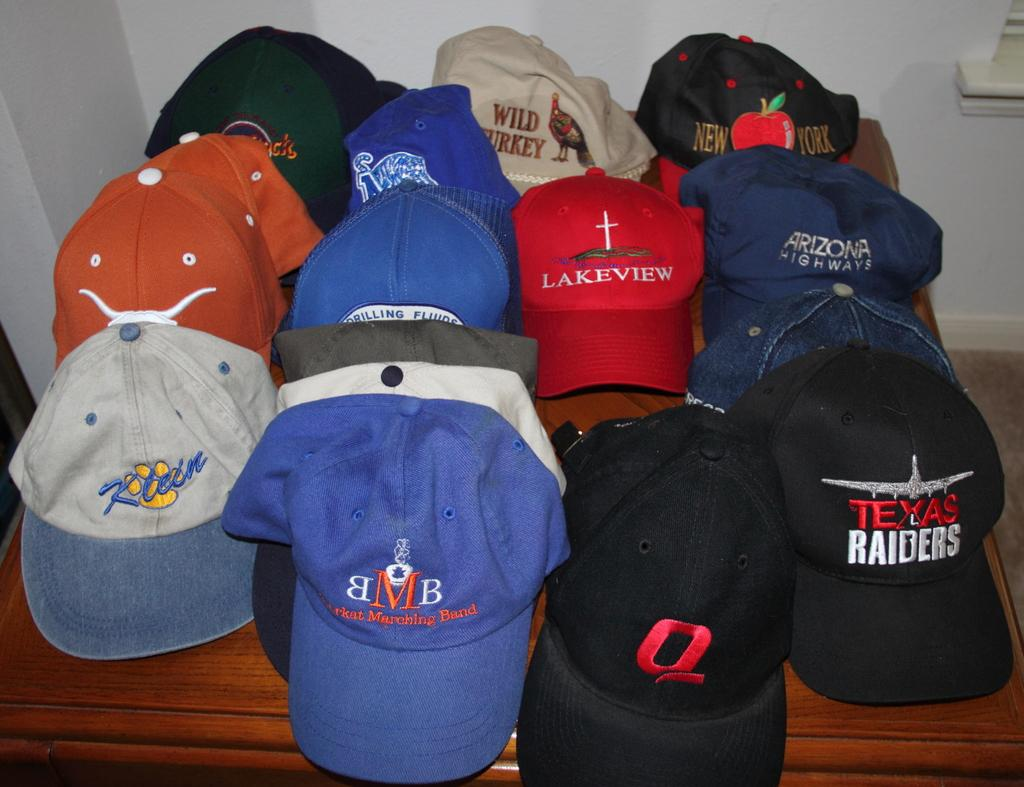<image>
Present a compact description of the photo's key features. A Texas Raiders hat sits among many other hats on a table. 